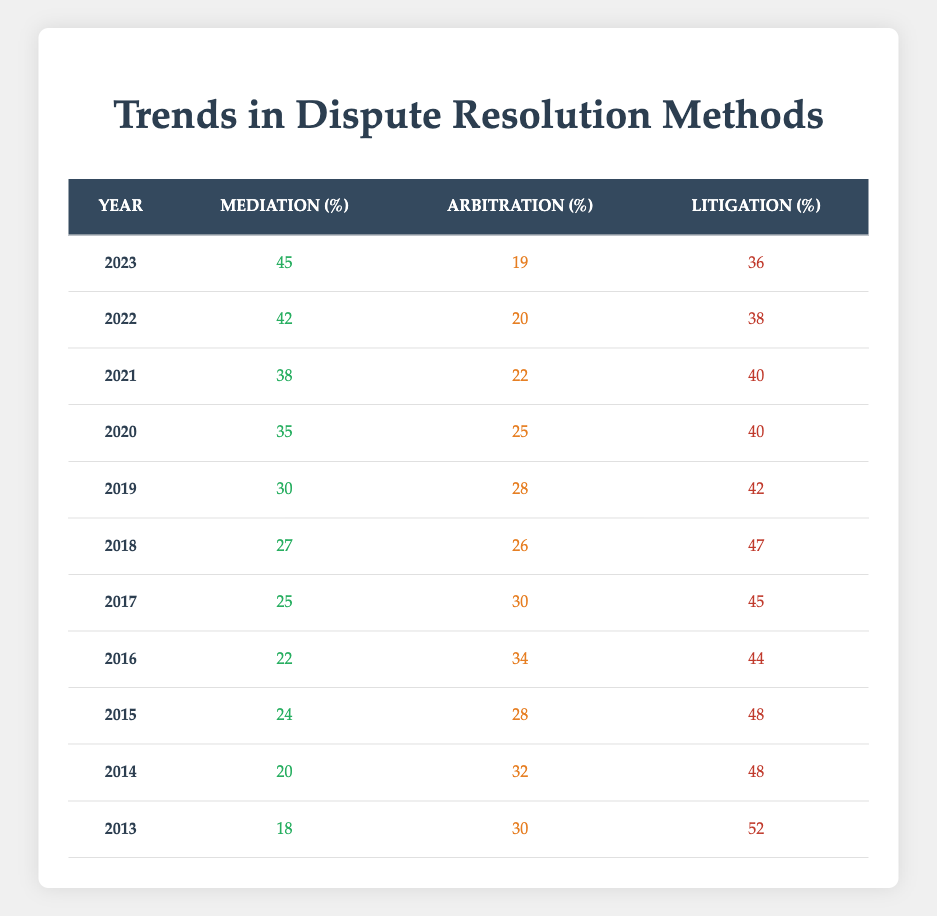What was the percentage of mediation used in 2023? The table shows that in 2023, the percentage of mediation is 45%.
Answer: 45% Which year had the highest percentage of litigation? Looking at the table, the year with the highest percentage of litigation is 2013, which is 52%.
Answer: 2013 What is the difference in percentage of arbitration between 2013 and 2023? In 2013, the arbitration percentage is 30% and in 2023 it is 19%. The difference is 30% - 19% = 11%.
Answer: 11% In which year did the use of mediation begin to exceed 30%? Reviewing the table, the percentage of mediation first exceeds 30% in 2019 when it reached 30%.
Answer: 2019 Is the percentage of arbitration in 2021 higher than in 2018? The table shows arbitration in 2018 is 26% and in 2021 it is 22%, meaning 2021 is lower than 2018.
Answer: No What is the average percentage of mediation from 2013 to 2023? First, sum the mediation percentages: 18 + 20 + 24 + 22 + 25 + 27 + 30 + 35 + 38 + 42 + 45 =  100. Then divide by 11 years: 100/11 = approximately 27.27%.
Answer: 27.27% In 2022, what was the combined percentage of mediation and arbitration? In 2022, the percentage of mediation is 42% and arbitration is 20%. The combined percentage is 42% + 20% = 62%.
Answer: 62% What trend is observed in mediation percentages from 2013 to 2023? Analyzing the table, mediation percentages show a consistent increase from 18% in 2013 to 45% in 2023.
Answer: Increasing trend Did the total percentage of dispute resolution methods ever exceed 100%? Since the percentages for mediation, arbitration, and litigation are calculated separately and always sum up to 100%, they do not exceed that value.
Answer: No What percentage of disputes were resolved through litigation in 2020? The table indicates that in 2020, the percentage of disputes resolved through litigation was 40%.
Answer: 40% How did the percentage of mediation change from 2021 to 2023? In 2021, mediation was at 38% and in 2023, it rose to 45%. The increase is 45% - 38% = 7%.
Answer: Increased by 7% 